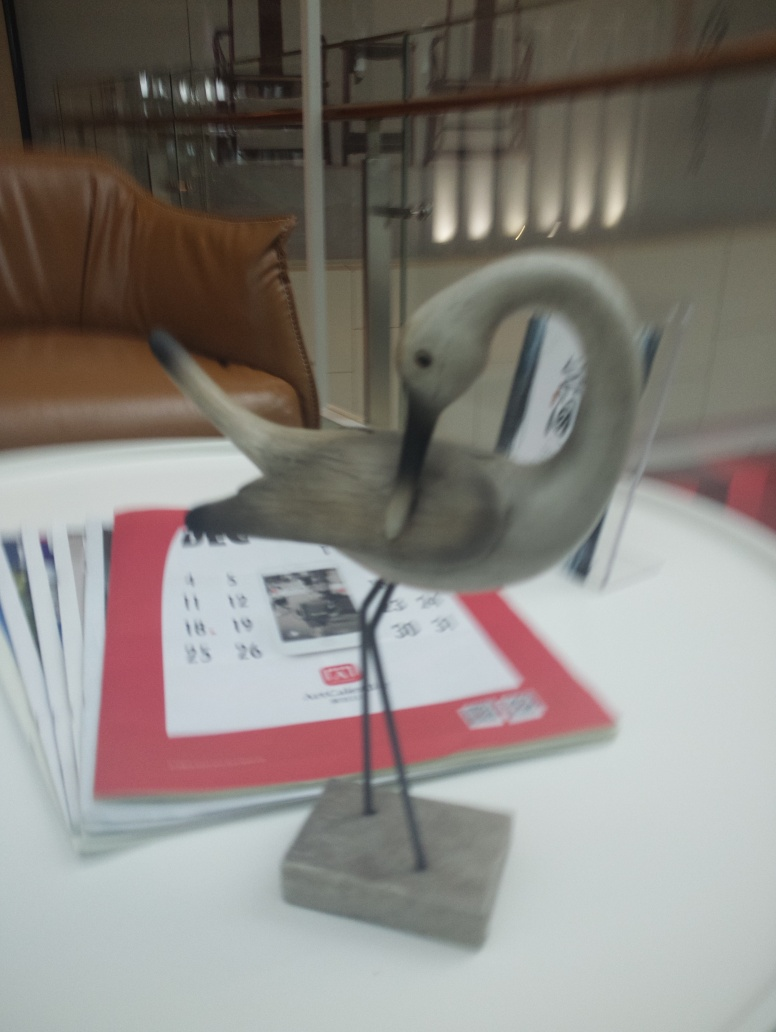Can you describe the setting where this image was taken? The image seems to be taken indoors, as indicated by the presence of a leather chair and shelving in the background. Elements such as paperwork and printed materials on the table suggest it could be an office or a waiting area. The setting has a professional and tidy atmosphere. 